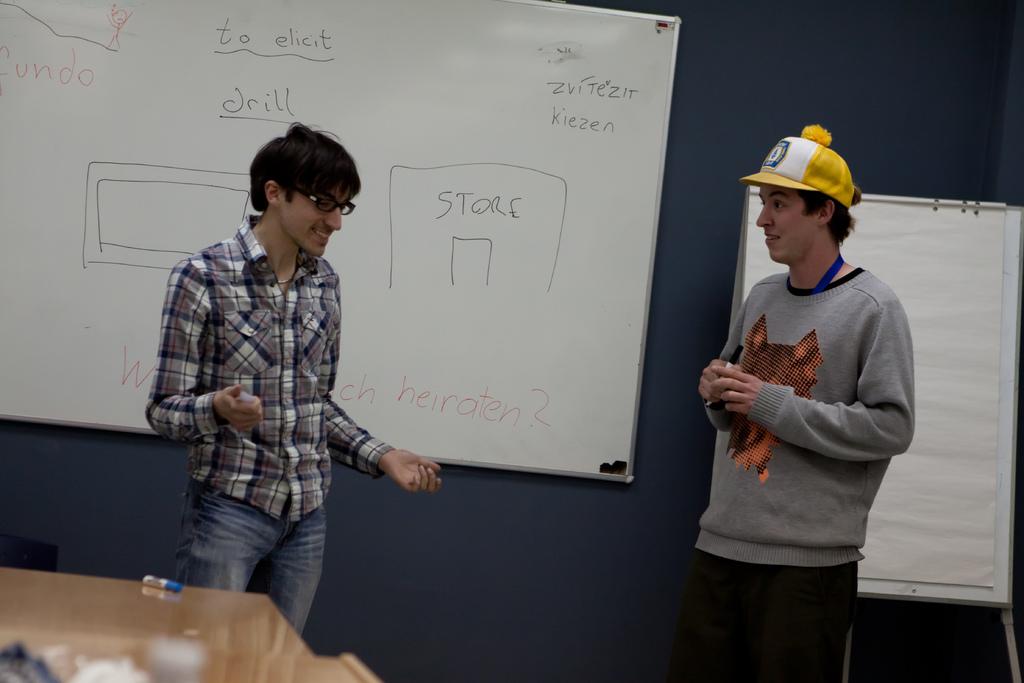What is on the white board?
Provide a succinct answer. Store. 